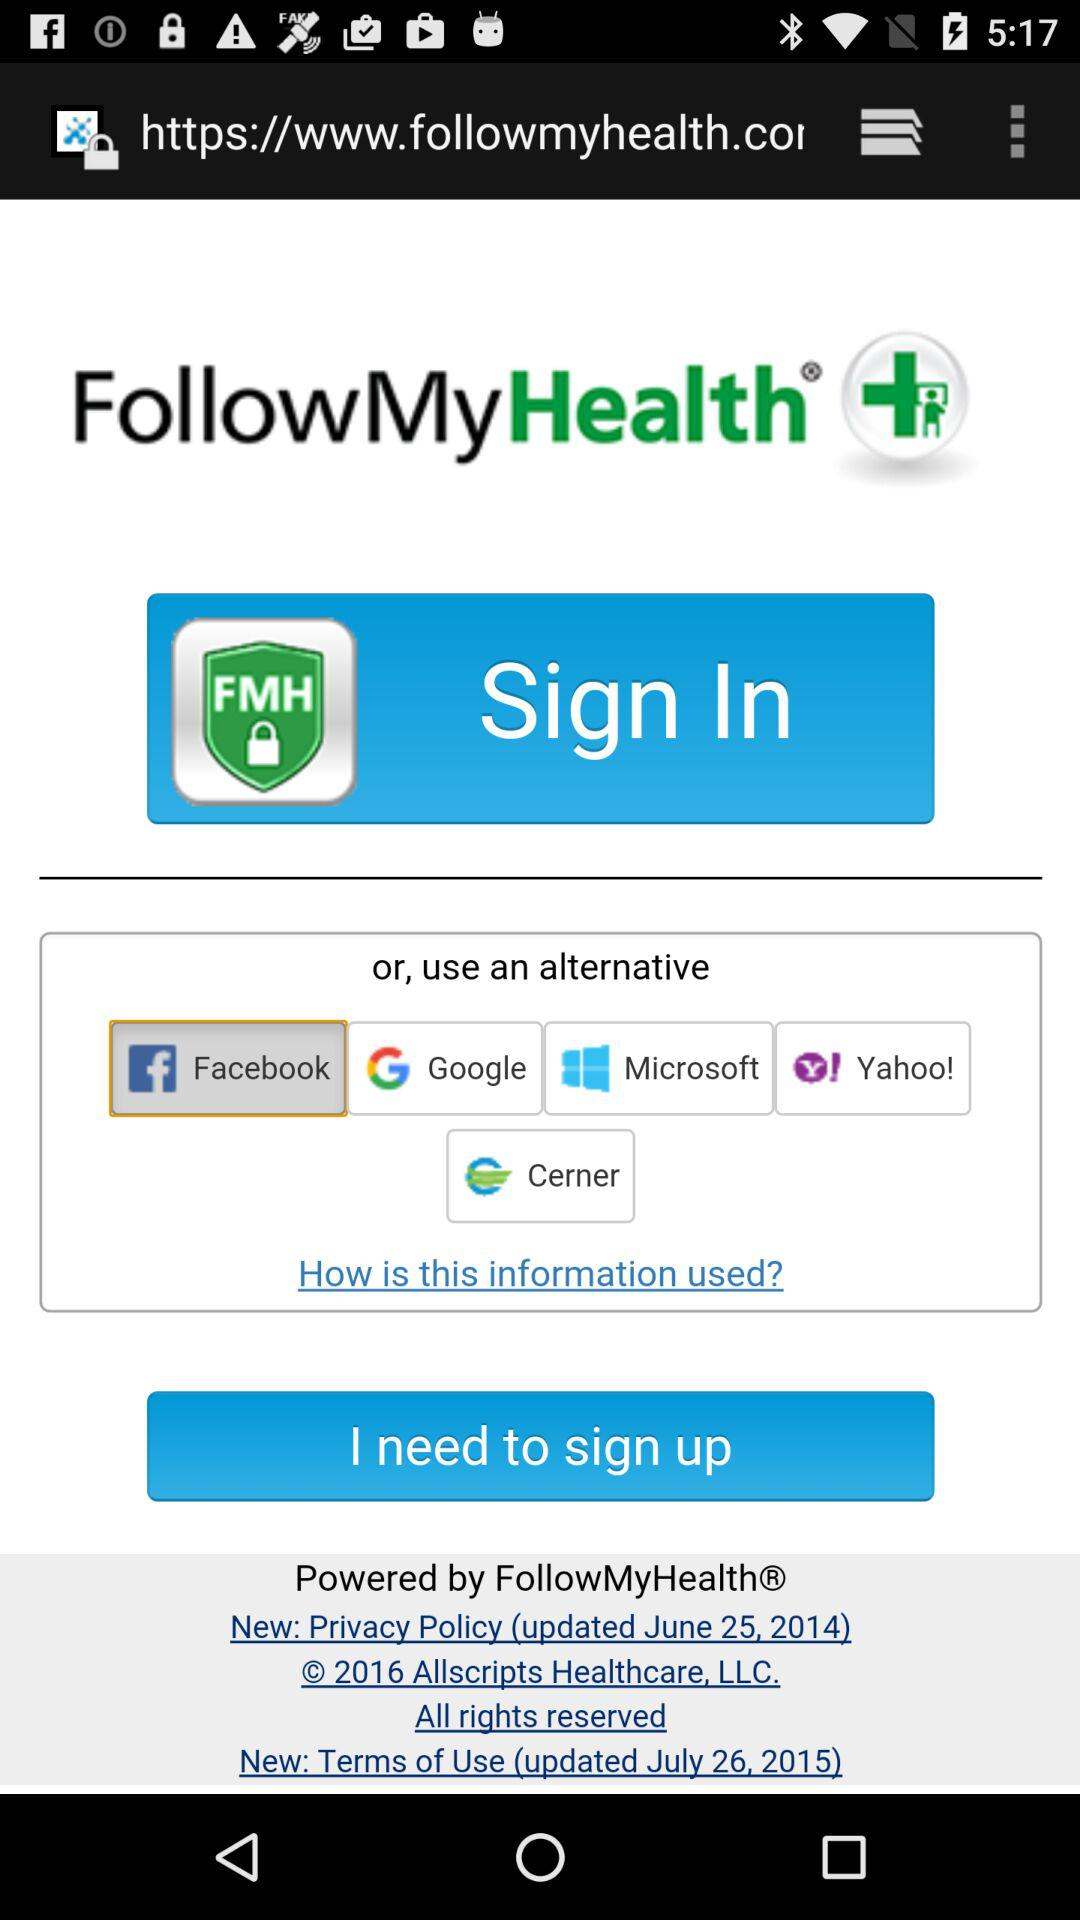What is the name of the application? The name of the application is "FollowMyHealth". 